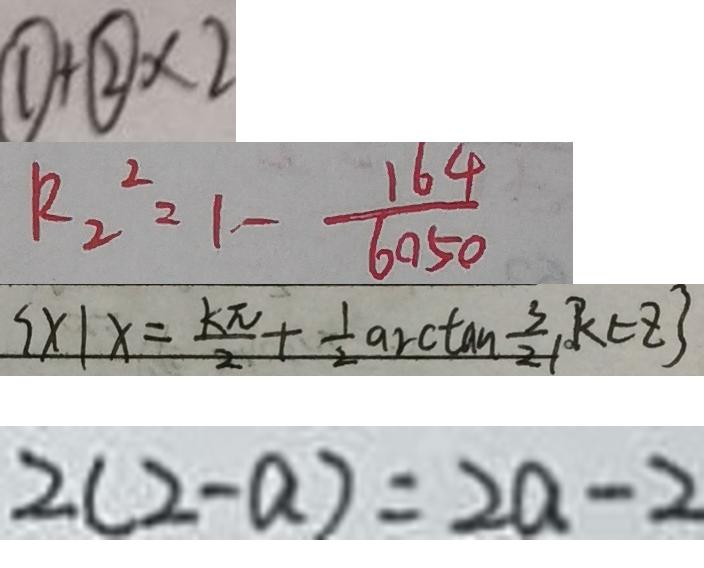<formula> <loc_0><loc_0><loc_500><loc_500>\textcircled { 1 } + \textcircled { 2 } \times 2 
 R _ { 2 } ^ { 2 } = 1 - \frac { 1 6 4 } { 6 0 5 0 } 
 \{ x \vert x = \frac { k \pi } { 2 } + \frac { 1 } { 2 } \arctan \frac { 3 } { 2 } k \in z \} 
 2 ( 2 - a ) = 2 a - 2</formula> 